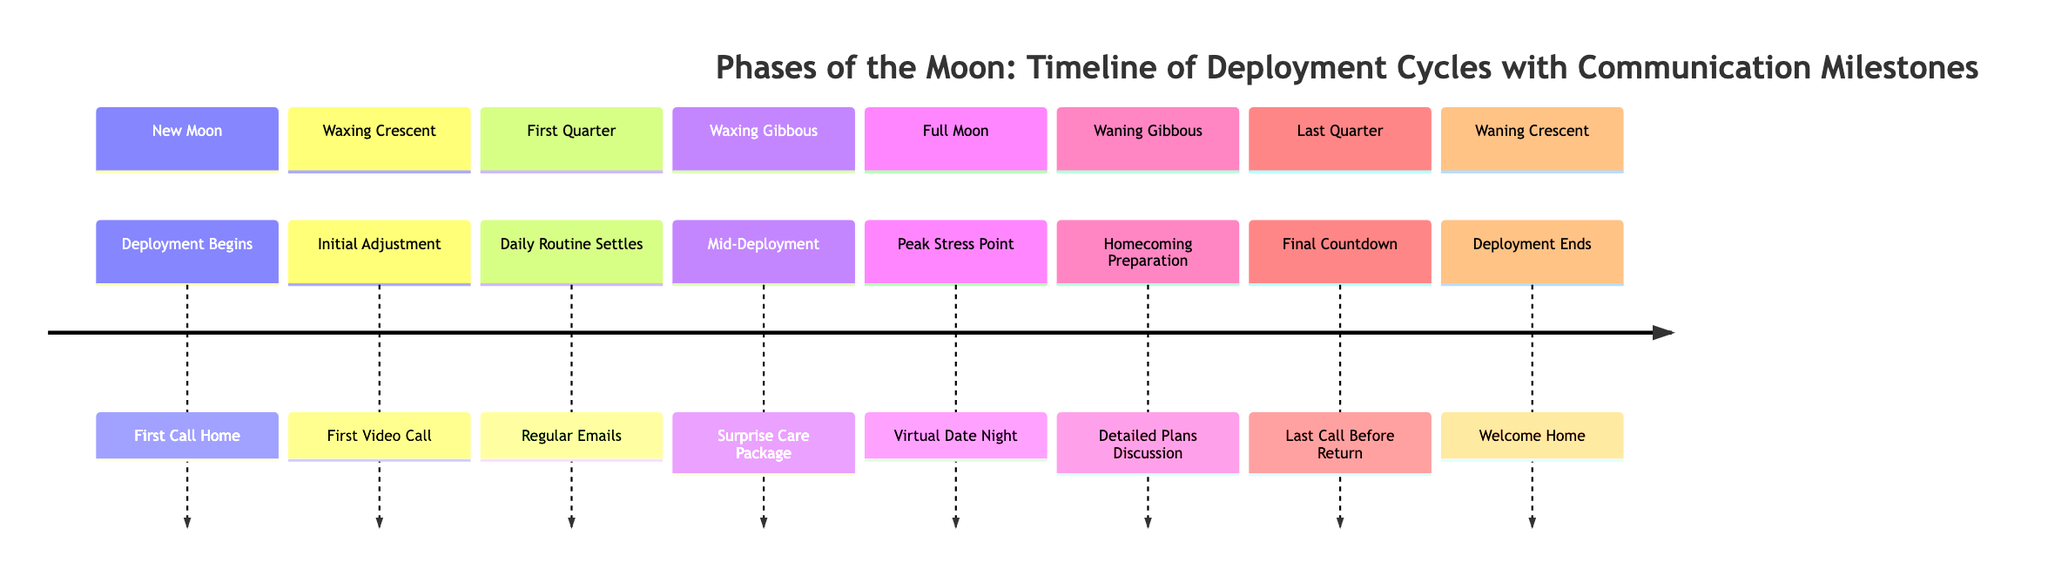What event marks the beginning of deployment? The diagram labels "Deployment Begins" as occurring during the New Moon phase, which indicates the start of the deployment cycle.
Answer: First Call Home What phase comes after the First Quarter? According to the sequence in the diagram, the Waxing Gibbous phase follows the First Quarter phase.
Answer: Waxing Gibbous How many communication milestones are listed in the timeline? By counting each of the sections in the diagram, one can determine that there are a total of seven distinct communication milestones.
Answer: 7 What is the peak stress point during deployment? The diagram clearly indicates that the peak stress point occurs during the Full Moon phase, which is labeled as "Peak Stress Point."
Answer: Virtual Date Night What does the Waning Crescent signify? In the diagram, the Waning Crescent phase is defined as "Deployment Ends," suggesting a conclusion to the deployment cycle.
Answer: Welcome Home Which phase includes the first video call? The section labeled "First Video Call" is associated with the Waxing Crescent phase in the timeline, indicating when this event occurs.
Answer: Waxing Crescent What does the Waning Gibbous section prepare for? The Waning Gibbous phase is dedicated to "Homecoming Preparation," signifying this time is focused on planning for the partner's return.
Answer: Detailed Plans Discussion During which phase is a surprise care package sent? The diagram explicitly connects the "Surprise Care Package" event with the Waxing Gibbous phase, highlighting this as a mid-deployment activity.
Answer: Waxing Gibbous 